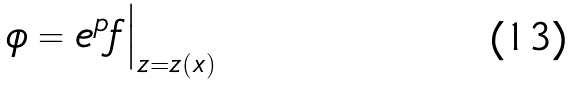<formula> <loc_0><loc_0><loc_500><loc_500>\phi = e ^ { p } f \Big | _ { z = z ( x ) }</formula> 